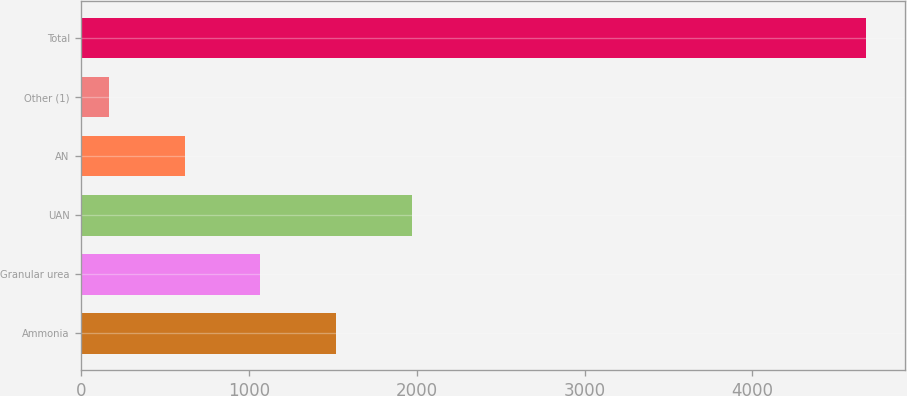Convert chart to OTSL. <chart><loc_0><loc_0><loc_500><loc_500><bar_chart><fcel>Ammonia<fcel>Granular urea<fcel>UAN<fcel>AN<fcel>Other (1)<fcel>Total<nl><fcel>1518.91<fcel>1067.64<fcel>1970.18<fcel>616.37<fcel>165.1<fcel>4677.8<nl></chart> 